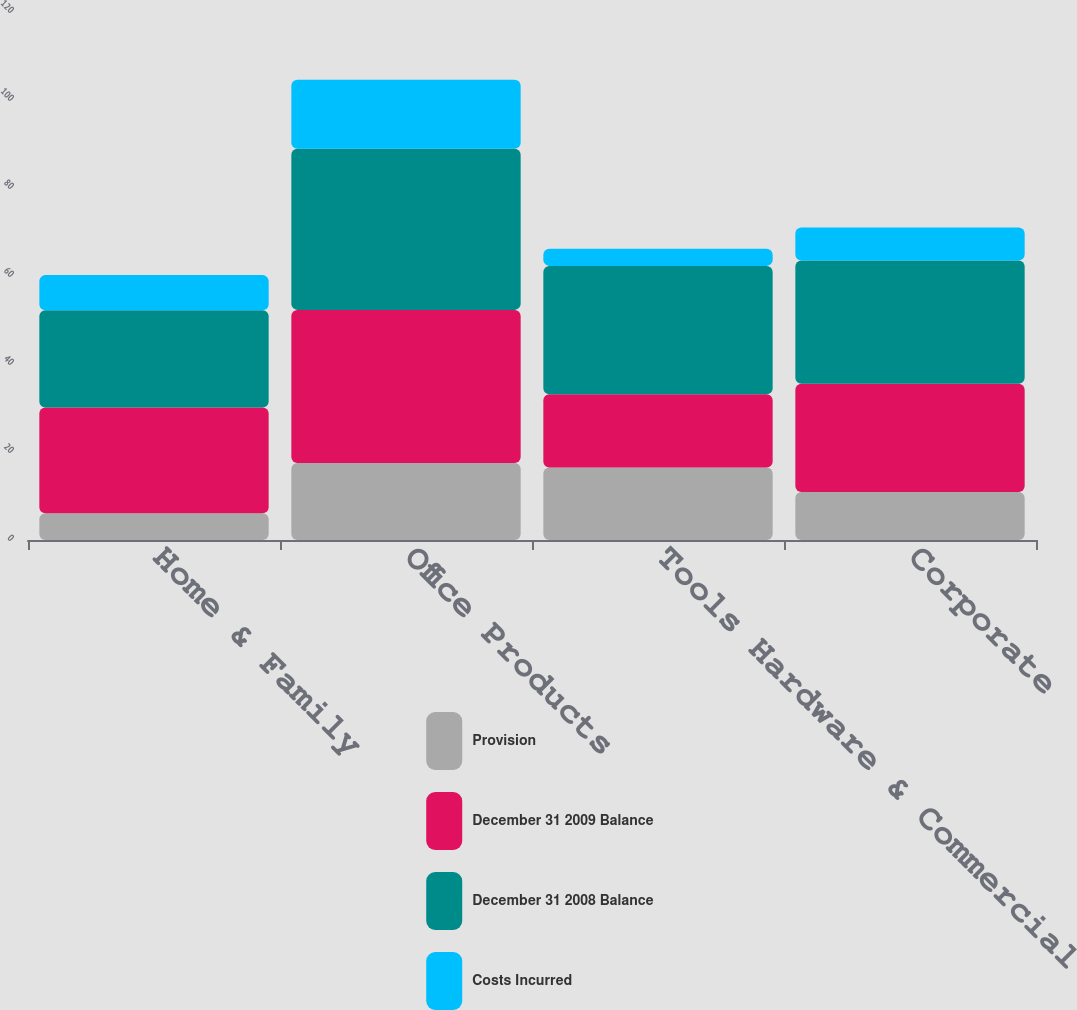Convert chart to OTSL. <chart><loc_0><loc_0><loc_500><loc_500><stacked_bar_chart><ecel><fcel>Home & Family<fcel>Office Products<fcel>Tools Hardware & Commercial<fcel>Corporate<nl><fcel>Provision<fcel>6.1<fcel>17.5<fcel>16.5<fcel>10.9<nl><fcel>December 31 2009 Balance<fcel>24<fcel>34.8<fcel>16.6<fcel>24.6<nl><fcel>December 31 2008 Balance<fcel>22.1<fcel>36.6<fcel>29.2<fcel>28<nl><fcel>Costs Incurred<fcel>8<fcel>15.7<fcel>3.9<fcel>7.5<nl></chart> 